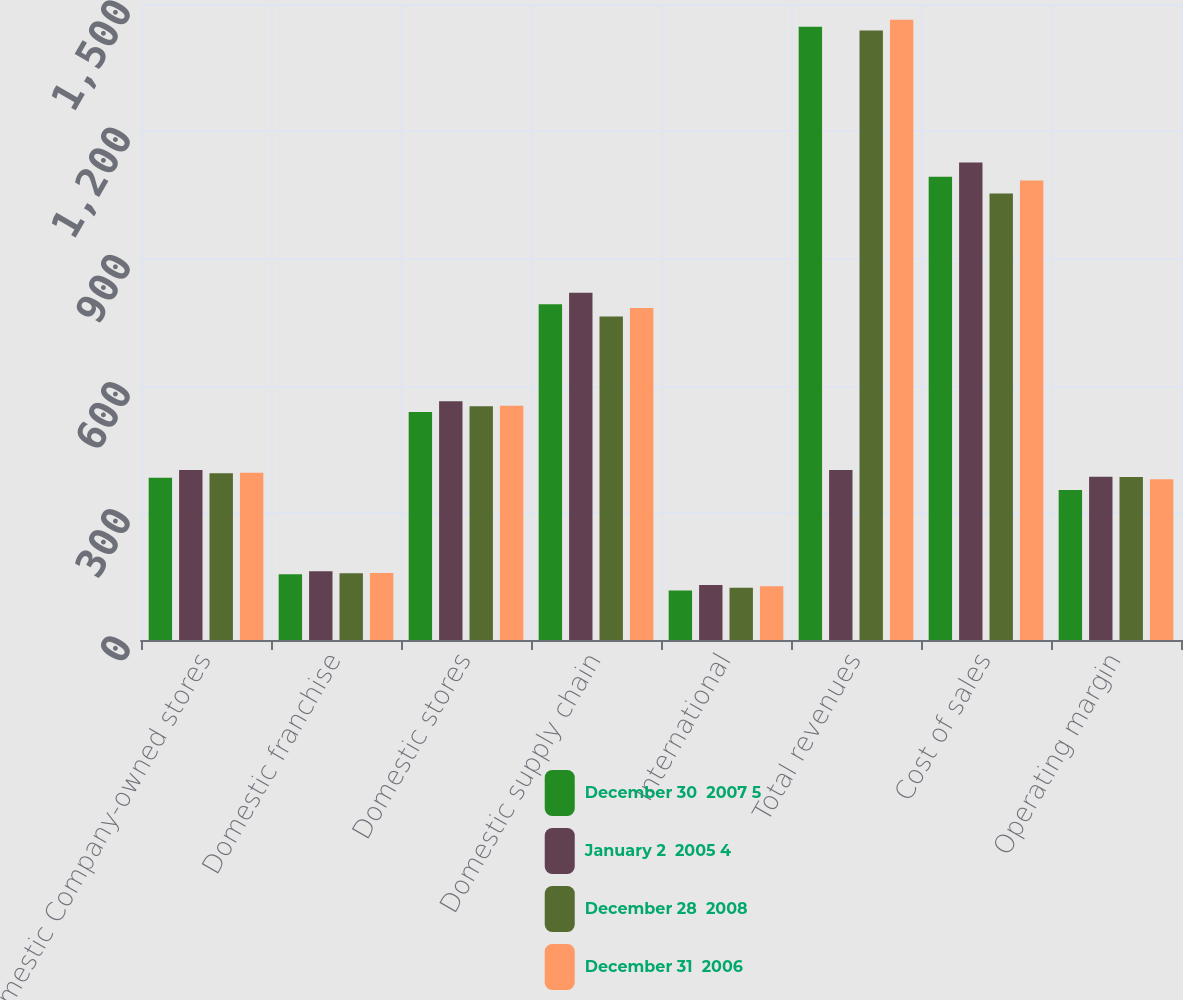Convert chart. <chart><loc_0><loc_0><loc_500><loc_500><stacked_bar_chart><ecel><fcel>Domestic Company-owned stores<fcel>Domestic franchise<fcel>Domestic stores<fcel>Domestic supply chain<fcel>International<fcel>Total revenues<fcel>Cost of sales<fcel>Operating margin<nl><fcel>December 30  2007 5<fcel>382.5<fcel>155<fcel>537.5<fcel>792<fcel>117<fcel>1446.5<fcel>1092.8<fcel>353.7<nl><fcel>January 2  2005 4<fcel>401<fcel>161.9<fcel>562.9<fcel>819.1<fcel>129.6<fcel>401<fcel>1126.3<fcel>385.3<nl><fcel>December 28  2008<fcel>393.4<fcel>157.7<fcel>551.1<fcel>762.8<fcel>123.4<fcel>1437.3<fcel>1052.8<fcel>384.5<nl><fcel>December 31  2006<fcel>394.6<fcel>158.1<fcel>552.6<fcel>783.3<fcel>126.9<fcel>1462.9<fcel>1084<fcel>378.9<nl></chart> 